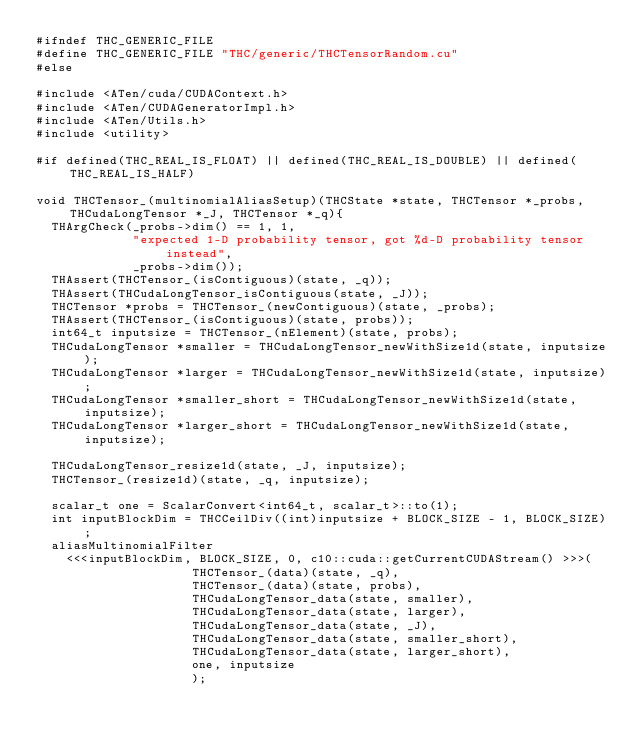<code> <loc_0><loc_0><loc_500><loc_500><_Cuda_>#ifndef THC_GENERIC_FILE
#define THC_GENERIC_FILE "THC/generic/THCTensorRandom.cu"
#else

#include <ATen/cuda/CUDAContext.h>
#include <ATen/CUDAGeneratorImpl.h>
#include <ATen/Utils.h>
#include <utility>

#if defined(THC_REAL_IS_FLOAT) || defined(THC_REAL_IS_DOUBLE) || defined(THC_REAL_IS_HALF)

void THCTensor_(multinomialAliasSetup)(THCState *state, THCTensor *_probs, THCudaLongTensor *_J, THCTensor *_q){
  THArgCheck(_probs->dim() == 1, 1,
             "expected 1-D probability tensor, got %d-D probability tensor instead",
             _probs->dim());
  THAssert(THCTensor_(isContiguous)(state, _q));
  THAssert(THCudaLongTensor_isContiguous(state, _J));
  THCTensor *probs = THCTensor_(newContiguous)(state, _probs);
  THAssert(THCTensor_(isContiguous)(state, probs));
  int64_t inputsize = THCTensor_(nElement)(state, probs);
  THCudaLongTensor *smaller = THCudaLongTensor_newWithSize1d(state, inputsize);
  THCudaLongTensor *larger = THCudaLongTensor_newWithSize1d(state, inputsize);
  THCudaLongTensor *smaller_short = THCudaLongTensor_newWithSize1d(state, inputsize);
  THCudaLongTensor *larger_short = THCudaLongTensor_newWithSize1d(state, inputsize);

  THCudaLongTensor_resize1d(state, _J, inputsize);
  THCTensor_(resize1d)(state, _q, inputsize);

  scalar_t one = ScalarConvert<int64_t, scalar_t>::to(1);
  int inputBlockDim = THCCeilDiv((int)inputsize + BLOCK_SIZE - 1, BLOCK_SIZE);
  aliasMultinomialFilter
    <<<inputBlockDim, BLOCK_SIZE, 0, c10::cuda::getCurrentCUDAStream() >>>(
                     THCTensor_(data)(state, _q),
                     THCTensor_(data)(state, probs),
                     THCudaLongTensor_data(state, smaller),
                     THCudaLongTensor_data(state, larger),
                     THCudaLongTensor_data(state, _J),
                     THCudaLongTensor_data(state, smaller_short),
                     THCudaLongTensor_data(state, larger_short),
                     one, inputsize
                     );</code> 